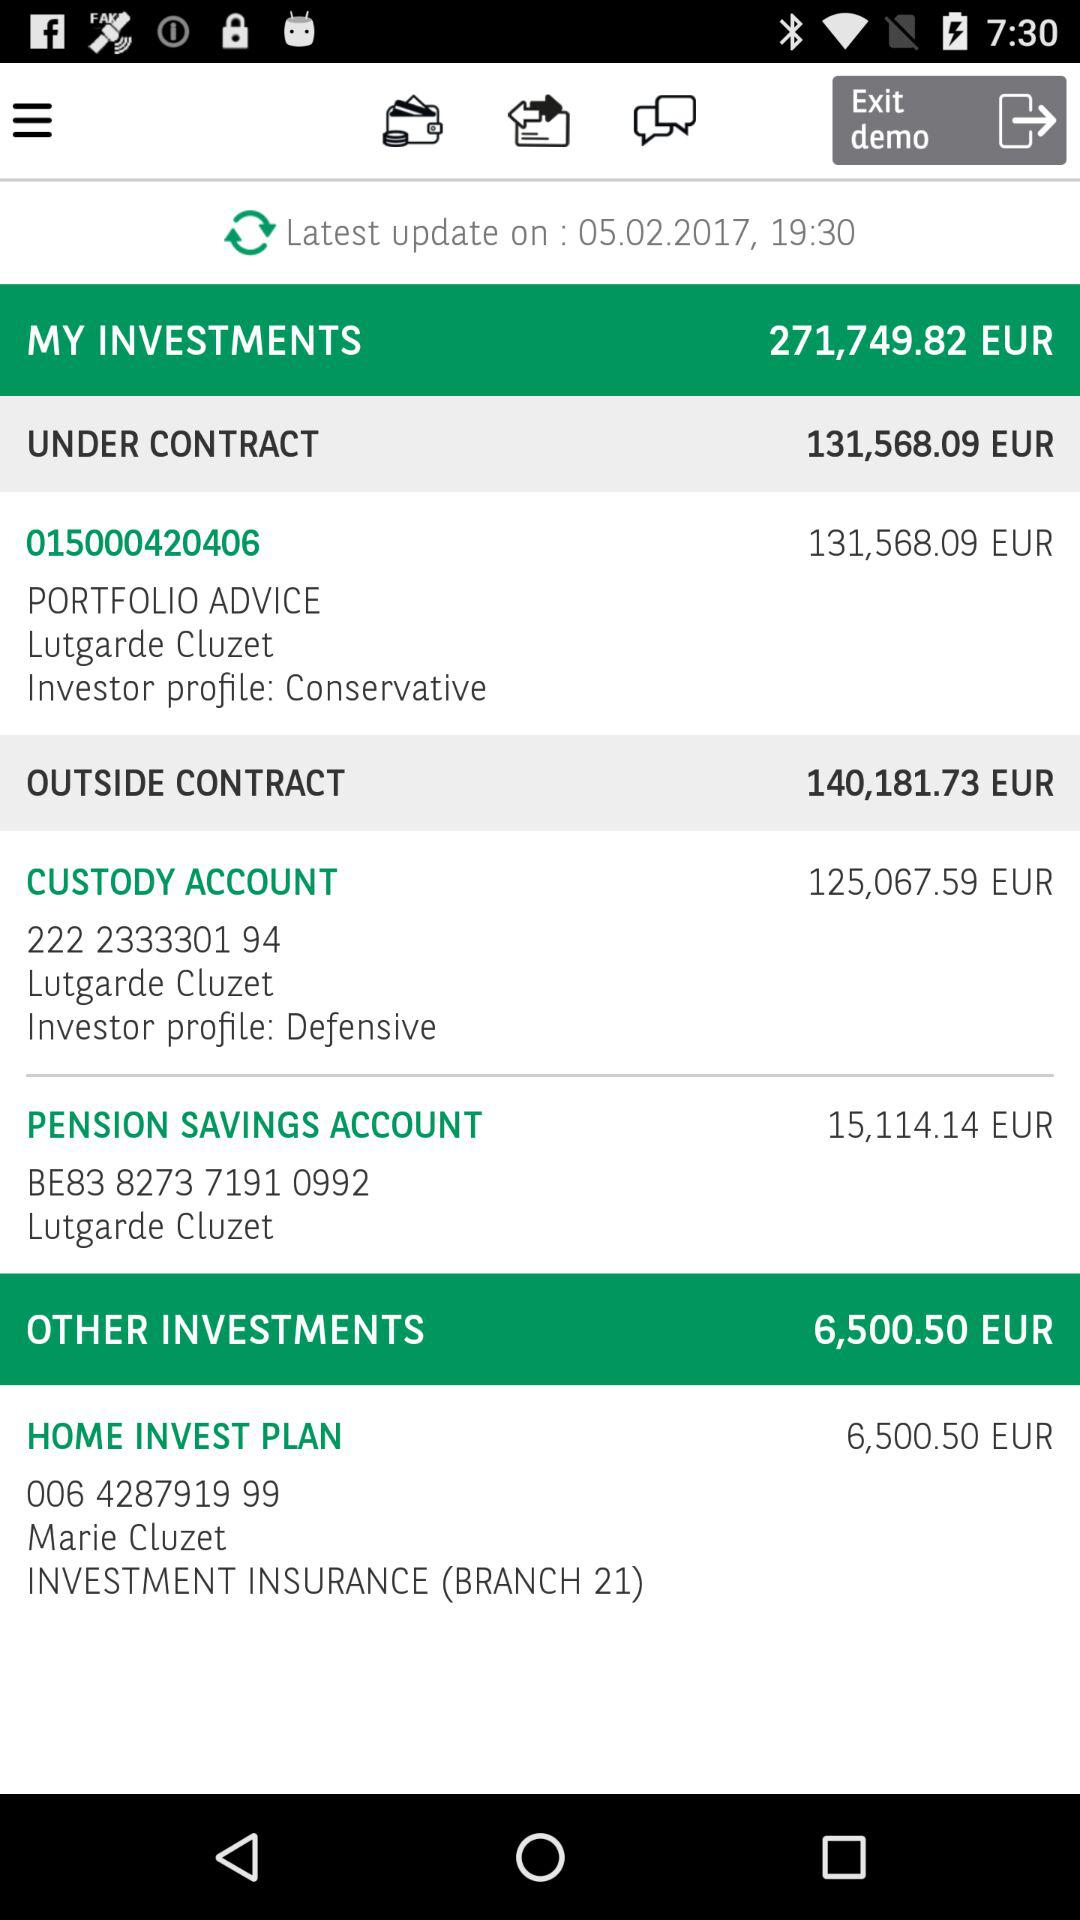What is the value of the pension savings account? The value of the pension savings account is 15,114.14 EUR. 